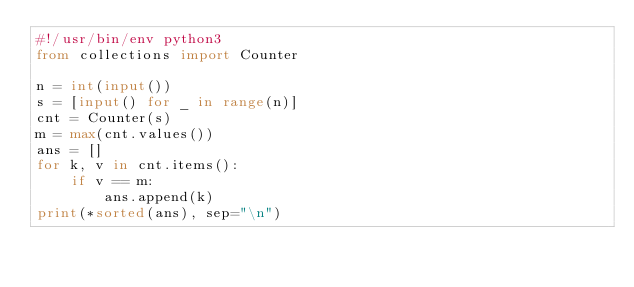Convert code to text. <code><loc_0><loc_0><loc_500><loc_500><_Python_>#!/usr/bin/env python3
from collections import Counter

n = int(input())
s = [input() for _ in range(n)]
cnt = Counter(s)
m = max(cnt.values())
ans = []
for k, v in cnt.items():
    if v == m:
        ans.append(k)
print(*sorted(ans), sep="\n")
</code> 